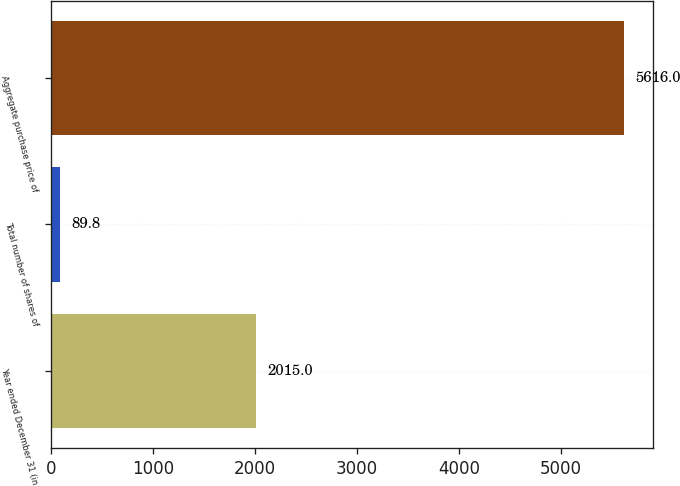<chart> <loc_0><loc_0><loc_500><loc_500><bar_chart><fcel>Year ended December 31 (in<fcel>Total number of shares of<fcel>Aggregate purchase price of<nl><fcel>2015<fcel>89.8<fcel>5616<nl></chart> 